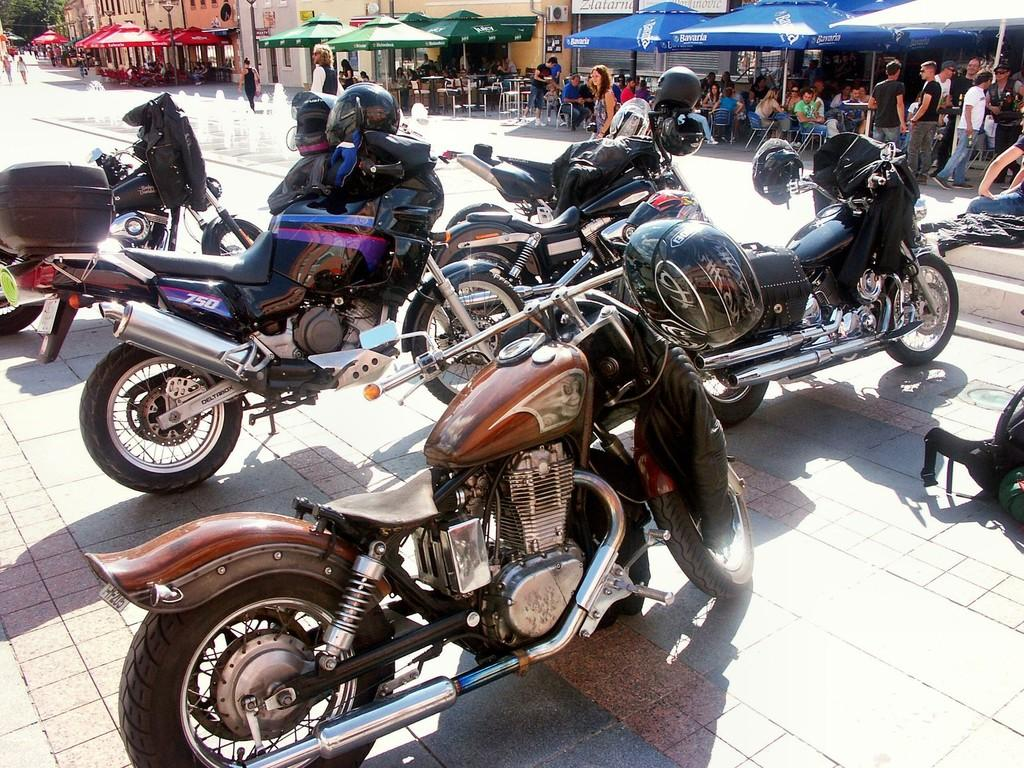What can be seen in the foreground of the image? There are bikes on the road in the foreground of the image. What is visible in the background of the image? There are stalls, buildings, and trees in the background of the image. Can you describe the people in the image? There are people sitting on chairs in the image. What type of bit is being used by the person getting a haircut in the image? There is no person getting a haircut in the image, and therefore no bit is present. What historical event is being commemorated in the image? There is no historical event being commemorated in the image. 